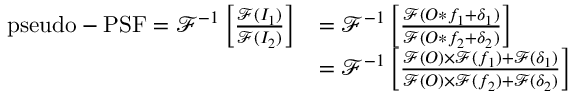<formula> <loc_0><loc_0><loc_500><loc_500>\begin{array} { r l } { p s e u d o - P S F = \mathcal { F } ^ { - 1 } \left [ \frac { \mathcal { F } ( I _ { 1 } ) } { \mathcal { F } ( I _ { 2 } ) } \right ] } & { = \mathcal { F } ^ { - 1 } \left [ \frac { \mathcal { F } ( O \ast f _ { 1 } + \delta _ { 1 } ) } { \mathcal { F } ( O \ast f _ { 2 } + \delta _ { 2 } ) } \right ] } \\ & { = \mathcal { F } ^ { - 1 } \left [ \frac { \mathcal { F } ( O ) \times \mathcal { F } ( f _ { 1 } ) + \mathcal { F } ( \delta _ { 1 } ) } { \mathcal { F } ( O ) \times \mathcal { F } ( f _ { 2 } ) + \mathcal { F } ( \delta _ { 2 } ) } \right ] } \end{array}</formula> 